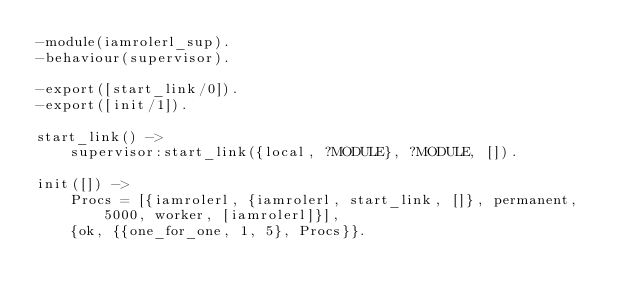Convert code to text. <code><loc_0><loc_0><loc_500><loc_500><_Erlang_>-module(iamrolerl_sup).
-behaviour(supervisor).

-export([start_link/0]).
-export([init/1]).

start_link() ->
	supervisor:start_link({local, ?MODULE}, ?MODULE, []).

init([]) ->
	Procs = [{iamrolerl, {iamrolerl, start_link, []}, permanent, 5000, worker, [iamrolerl]}],
	{ok, {{one_for_one, 1, 5}, Procs}}.
</code> 